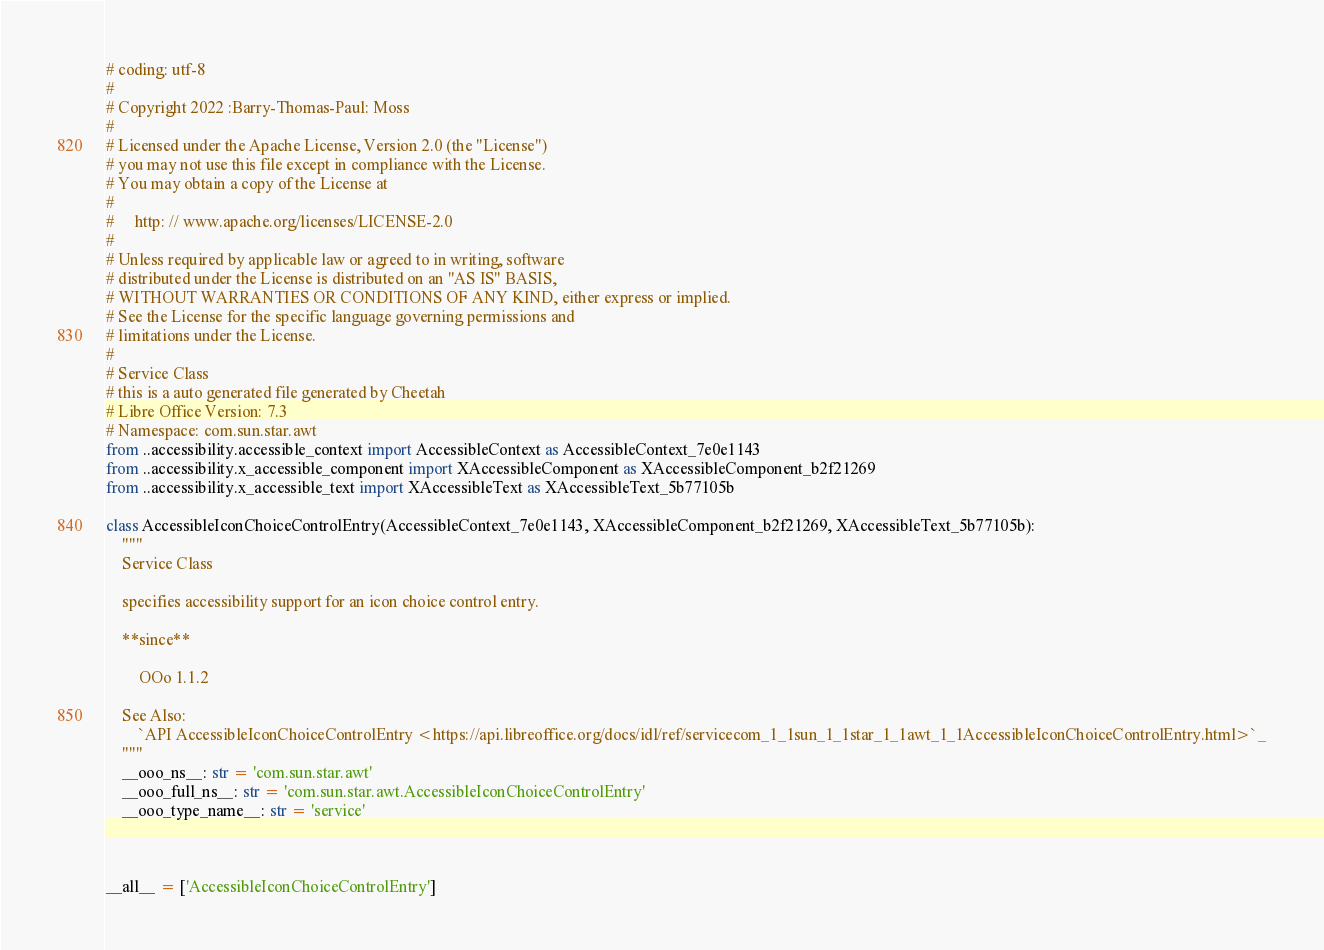<code> <loc_0><loc_0><loc_500><loc_500><_Python_># coding: utf-8
#
# Copyright 2022 :Barry-Thomas-Paul: Moss
#
# Licensed under the Apache License, Version 2.0 (the "License")
# you may not use this file except in compliance with the License.
# You may obtain a copy of the License at
#
#     http: // www.apache.org/licenses/LICENSE-2.0
#
# Unless required by applicable law or agreed to in writing, software
# distributed under the License is distributed on an "AS IS" BASIS,
# WITHOUT WARRANTIES OR CONDITIONS OF ANY KIND, either express or implied.
# See the License for the specific language governing permissions and
# limitations under the License.
#
# Service Class
# this is a auto generated file generated by Cheetah
# Libre Office Version: 7.3
# Namespace: com.sun.star.awt
from ..accessibility.accessible_context import AccessibleContext as AccessibleContext_7e0e1143
from ..accessibility.x_accessible_component import XAccessibleComponent as XAccessibleComponent_b2f21269
from ..accessibility.x_accessible_text import XAccessibleText as XAccessibleText_5b77105b

class AccessibleIconChoiceControlEntry(AccessibleContext_7e0e1143, XAccessibleComponent_b2f21269, XAccessibleText_5b77105b):
    """
    Service Class

    specifies accessibility support for an icon choice control entry.
    
    **since**
    
        OOo 1.1.2

    See Also:
        `API AccessibleIconChoiceControlEntry <https://api.libreoffice.org/docs/idl/ref/servicecom_1_1sun_1_1star_1_1awt_1_1AccessibleIconChoiceControlEntry.html>`_
    """
    __ooo_ns__: str = 'com.sun.star.awt'
    __ooo_full_ns__: str = 'com.sun.star.awt.AccessibleIconChoiceControlEntry'
    __ooo_type_name__: str = 'service'



__all__ = ['AccessibleIconChoiceControlEntry']

</code> 